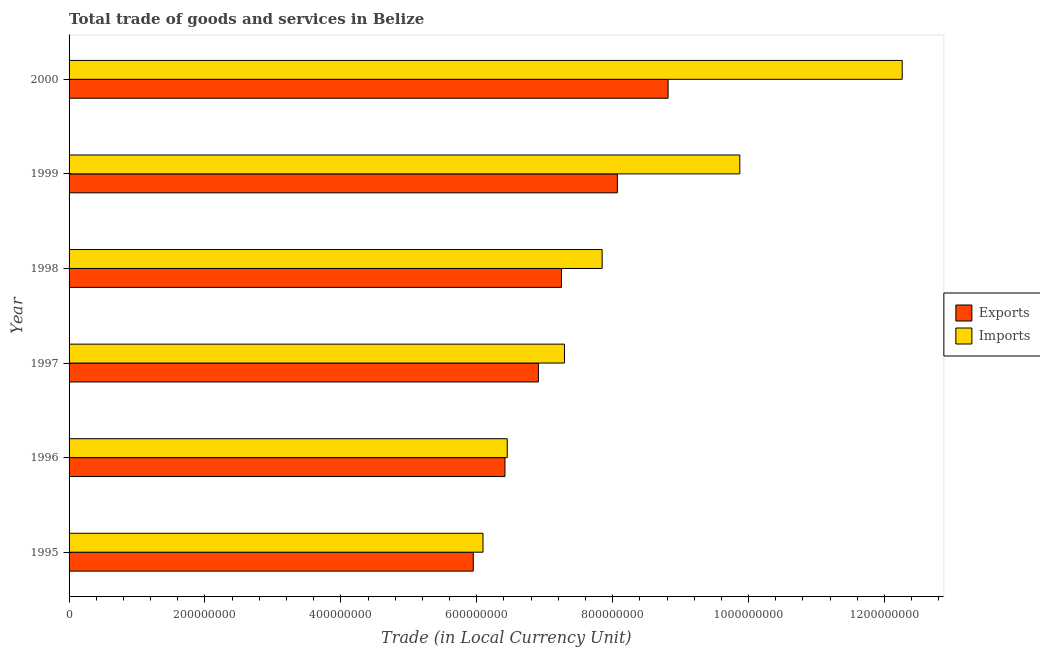Are the number of bars per tick equal to the number of legend labels?
Offer a very short reply. Yes. Are the number of bars on each tick of the Y-axis equal?
Offer a terse response. Yes. How many bars are there on the 3rd tick from the top?
Ensure brevity in your answer.  2. How many bars are there on the 3rd tick from the bottom?
Keep it short and to the point. 2. What is the label of the 6th group of bars from the top?
Give a very brief answer. 1995. In how many cases, is the number of bars for a given year not equal to the number of legend labels?
Your answer should be very brief. 0. What is the imports of goods and services in 2000?
Your response must be concise. 1.23e+09. Across all years, what is the maximum imports of goods and services?
Offer a terse response. 1.23e+09. Across all years, what is the minimum export of goods and services?
Your answer should be very brief. 5.95e+08. What is the total imports of goods and services in the graph?
Offer a terse response. 4.98e+09. What is the difference between the export of goods and services in 1995 and that in 1999?
Offer a terse response. -2.12e+08. What is the difference between the imports of goods and services in 2000 and the export of goods and services in 1996?
Make the answer very short. 5.85e+08. What is the average export of goods and services per year?
Offer a very short reply. 7.23e+08. In the year 2000, what is the difference between the export of goods and services and imports of goods and services?
Ensure brevity in your answer.  -3.44e+08. What is the ratio of the export of goods and services in 1999 to that in 2000?
Your response must be concise. 0.92. What is the difference between the highest and the second highest imports of goods and services?
Provide a short and direct response. 2.39e+08. What is the difference between the highest and the lowest imports of goods and services?
Provide a succinct answer. 6.17e+08. Is the sum of the imports of goods and services in 1995 and 1998 greater than the maximum export of goods and services across all years?
Provide a short and direct response. Yes. What does the 2nd bar from the top in 1996 represents?
Offer a very short reply. Exports. What does the 2nd bar from the bottom in 1998 represents?
Ensure brevity in your answer.  Imports. Are the values on the major ticks of X-axis written in scientific E-notation?
Your answer should be compact. No. Where does the legend appear in the graph?
Your answer should be compact. Center right. What is the title of the graph?
Make the answer very short. Total trade of goods and services in Belize. What is the label or title of the X-axis?
Offer a very short reply. Trade (in Local Currency Unit). What is the label or title of the Y-axis?
Your answer should be very brief. Year. What is the Trade (in Local Currency Unit) in Exports in 1995?
Provide a short and direct response. 5.95e+08. What is the Trade (in Local Currency Unit) in Imports in 1995?
Your answer should be compact. 6.09e+08. What is the Trade (in Local Currency Unit) of Exports in 1996?
Your response must be concise. 6.41e+08. What is the Trade (in Local Currency Unit) in Imports in 1996?
Ensure brevity in your answer.  6.45e+08. What is the Trade (in Local Currency Unit) in Exports in 1997?
Offer a terse response. 6.91e+08. What is the Trade (in Local Currency Unit) of Imports in 1997?
Offer a very short reply. 7.29e+08. What is the Trade (in Local Currency Unit) of Exports in 1998?
Provide a short and direct response. 7.25e+08. What is the Trade (in Local Currency Unit) of Imports in 1998?
Offer a very short reply. 7.84e+08. What is the Trade (in Local Currency Unit) in Exports in 1999?
Make the answer very short. 8.07e+08. What is the Trade (in Local Currency Unit) of Imports in 1999?
Ensure brevity in your answer.  9.87e+08. What is the Trade (in Local Currency Unit) of Exports in 2000?
Make the answer very short. 8.82e+08. What is the Trade (in Local Currency Unit) of Imports in 2000?
Provide a succinct answer. 1.23e+09. Across all years, what is the maximum Trade (in Local Currency Unit) of Exports?
Give a very brief answer. 8.82e+08. Across all years, what is the maximum Trade (in Local Currency Unit) of Imports?
Offer a very short reply. 1.23e+09. Across all years, what is the minimum Trade (in Local Currency Unit) in Exports?
Ensure brevity in your answer.  5.95e+08. Across all years, what is the minimum Trade (in Local Currency Unit) of Imports?
Your answer should be compact. 6.09e+08. What is the total Trade (in Local Currency Unit) of Exports in the graph?
Your answer should be compact. 4.34e+09. What is the total Trade (in Local Currency Unit) of Imports in the graph?
Make the answer very short. 4.98e+09. What is the difference between the Trade (in Local Currency Unit) in Exports in 1995 and that in 1996?
Provide a succinct answer. -4.66e+07. What is the difference between the Trade (in Local Currency Unit) in Imports in 1995 and that in 1996?
Make the answer very short. -3.57e+07. What is the difference between the Trade (in Local Currency Unit) in Exports in 1995 and that in 1997?
Offer a very short reply. -9.58e+07. What is the difference between the Trade (in Local Currency Unit) of Imports in 1995 and that in 1997?
Your answer should be compact. -1.20e+08. What is the difference between the Trade (in Local Currency Unit) of Exports in 1995 and that in 1998?
Your response must be concise. -1.30e+08. What is the difference between the Trade (in Local Currency Unit) of Imports in 1995 and that in 1998?
Provide a succinct answer. -1.75e+08. What is the difference between the Trade (in Local Currency Unit) of Exports in 1995 and that in 1999?
Ensure brevity in your answer.  -2.12e+08. What is the difference between the Trade (in Local Currency Unit) in Imports in 1995 and that in 1999?
Provide a succinct answer. -3.78e+08. What is the difference between the Trade (in Local Currency Unit) of Exports in 1995 and that in 2000?
Give a very brief answer. -2.87e+08. What is the difference between the Trade (in Local Currency Unit) of Imports in 1995 and that in 2000?
Offer a very short reply. -6.17e+08. What is the difference between the Trade (in Local Currency Unit) in Exports in 1996 and that in 1997?
Your answer should be compact. -4.93e+07. What is the difference between the Trade (in Local Currency Unit) in Imports in 1996 and that in 1997?
Provide a short and direct response. -8.42e+07. What is the difference between the Trade (in Local Currency Unit) of Exports in 1996 and that in 1998?
Keep it short and to the point. -8.31e+07. What is the difference between the Trade (in Local Currency Unit) in Imports in 1996 and that in 1998?
Offer a terse response. -1.40e+08. What is the difference between the Trade (in Local Currency Unit) in Exports in 1996 and that in 1999?
Keep it short and to the point. -1.65e+08. What is the difference between the Trade (in Local Currency Unit) in Imports in 1996 and that in 1999?
Give a very brief answer. -3.42e+08. What is the difference between the Trade (in Local Currency Unit) in Exports in 1996 and that in 2000?
Offer a terse response. -2.40e+08. What is the difference between the Trade (in Local Currency Unit) in Imports in 1996 and that in 2000?
Provide a succinct answer. -5.81e+08. What is the difference between the Trade (in Local Currency Unit) of Exports in 1997 and that in 1998?
Provide a succinct answer. -3.39e+07. What is the difference between the Trade (in Local Currency Unit) in Imports in 1997 and that in 1998?
Your response must be concise. -5.55e+07. What is the difference between the Trade (in Local Currency Unit) in Exports in 1997 and that in 1999?
Offer a terse response. -1.16e+08. What is the difference between the Trade (in Local Currency Unit) of Imports in 1997 and that in 1999?
Make the answer very short. -2.58e+08. What is the difference between the Trade (in Local Currency Unit) in Exports in 1997 and that in 2000?
Your answer should be compact. -1.91e+08. What is the difference between the Trade (in Local Currency Unit) in Imports in 1997 and that in 2000?
Your answer should be very brief. -4.97e+08. What is the difference between the Trade (in Local Currency Unit) in Exports in 1998 and that in 1999?
Your response must be concise. -8.23e+07. What is the difference between the Trade (in Local Currency Unit) of Imports in 1998 and that in 1999?
Provide a succinct answer. -2.03e+08. What is the difference between the Trade (in Local Currency Unit) in Exports in 1998 and that in 2000?
Keep it short and to the point. -1.57e+08. What is the difference between the Trade (in Local Currency Unit) in Imports in 1998 and that in 2000?
Your response must be concise. -4.42e+08. What is the difference between the Trade (in Local Currency Unit) in Exports in 1999 and that in 2000?
Ensure brevity in your answer.  -7.47e+07. What is the difference between the Trade (in Local Currency Unit) of Imports in 1999 and that in 2000?
Offer a very short reply. -2.39e+08. What is the difference between the Trade (in Local Currency Unit) in Exports in 1995 and the Trade (in Local Currency Unit) in Imports in 1996?
Your response must be concise. -4.99e+07. What is the difference between the Trade (in Local Currency Unit) of Exports in 1995 and the Trade (in Local Currency Unit) of Imports in 1997?
Provide a short and direct response. -1.34e+08. What is the difference between the Trade (in Local Currency Unit) in Exports in 1995 and the Trade (in Local Currency Unit) in Imports in 1998?
Your answer should be compact. -1.90e+08. What is the difference between the Trade (in Local Currency Unit) in Exports in 1995 and the Trade (in Local Currency Unit) in Imports in 1999?
Your answer should be very brief. -3.92e+08. What is the difference between the Trade (in Local Currency Unit) in Exports in 1995 and the Trade (in Local Currency Unit) in Imports in 2000?
Offer a terse response. -6.31e+08. What is the difference between the Trade (in Local Currency Unit) of Exports in 1996 and the Trade (in Local Currency Unit) of Imports in 1997?
Offer a terse response. -8.76e+07. What is the difference between the Trade (in Local Currency Unit) in Exports in 1996 and the Trade (in Local Currency Unit) in Imports in 1998?
Your response must be concise. -1.43e+08. What is the difference between the Trade (in Local Currency Unit) of Exports in 1996 and the Trade (in Local Currency Unit) of Imports in 1999?
Offer a terse response. -3.46e+08. What is the difference between the Trade (in Local Currency Unit) of Exports in 1996 and the Trade (in Local Currency Unit) of Imports in 2000?
Make the answer very short. -5.85e+08. What is the difference between the Trade (in Local Currency Unit) in Exports in 1997 and the Trade (in Local Currency Unit) in Imports in 1998?
Your response must be concise. -9.38e+07. What is the difference between the Trade (in Local Currency Unit) in Exports in 1997 and the Trade (in Local Currency Unit) in Imports in 1999?
Your response must be concise. -2.96e+08. What is the difference between the Trade (in Local Currency Unit) in Exports in 1997 and the Trade (in Local Currency Unit) in Imports in 2000?
Provide a short and direct response. -5.35e+08. What is the difference between the Trade (in Local Currency Unit) of Exports in 1998 and the Trade (in Local Currency Unit) of Imports in 1999?
Make the answer very short. -2.62e+08. What is the difference between the Trade (in Local Currency Unit) of Exports in 1998 and the Trade (in Local Currency Unit) of Imports in 2000?
Keep it short and to the point. -5.01e+08. What is the difference between the Trade (in Local Currency Unit) in Exports in 1999 and the Trade (in Local Currency Unit) in Imports in 2000?
Offer a very short reply. -4.19e+08. What is the average Trade (in Local Currency Unit) in Exports per year?
Ensure brevity in your answer.  7.23e+08. What is the average Trade (in Local Currency Unit) of Imports per year?
Provide a succinct answer. 8.30e+08. In the year 1995, what is the difference between the Trade (in Local Currency Unit) in Exports and Trade (in Local Currency Unit) in Imports?
Give a very brief answer. -1.43e+07. In the year 1996, what is the difference between the Trade (in Local Currency Unit) of Exports and Trade (in Local Currency Unit) of Imports?
Offer a very short reply. -3.37e+06. In the year 1997, what is the difference between the Trade (in Local Currency Unit) in Exports and Trade (in Local Currency Unit) in Imports?
Your answer should be very brief. -3.83e+07. In the year 1998, what is the difference between the Trade (in Local Currency Unit) of Exports and Trade (in Local Currency Unit) of Imports?
Keep it short and to the point. -5.99e+07. In the year 1999, what is the difference between the Trade (in Local Currency Unit) of Exports and Trade (in Local Currency Unit) of Imports?
Offer a very short reply. -1.80e+08. In the year 2000, what is the difference between the Trade (in Local Currency Unit) of Exports and Trade (in Local Currency Unit) of Imports?
Keep it short and to the point. -3.44e+08. What is the ratio of the Trade (in Local Currency Unit) of Exports in 1995 to that in 1996?
Offer a very short reply. 0.93. What is the ratio of the Trade (in Local Currency Unit) of Imports in 1995 to that in 1996?
Your answer should be compact. 0.94. What is the ratio of the Trade (in Local Currency Unit) of Exports in 1995 to that in 1997?
Keep it short and to the point. 0.86. What is the ratio of the Trade (in Local Currency Unit) of Imports in 1995 to that in 1997?
Ensure brevity in your answer.  0.84. What is the ratio of the Trade (in Local Currency Unit) of Exports in 1995 to that in 1998?
Offer a very short reply. 0.82. What is the ratio of the Trade (in Local Currency Unit) of Imports in 1995 to that in 1998?
Offer a very short reply. 0.78. What is the ratio of the Trade (in Local Currency Unit) of Exports in 1995 to that in 1999?
Give a very brief answer. 0.74. What is the ratio of the Trade (in Local Currency Unit) of Imports in 1995 to that in 1999?
Keep it short and to the point. 0.62. What is the ratio of the Trade (in Local Currency Unit) in Exports in 1995 to that in 2000?
Your answer should be compact. 0.67. What is the ratio of the Trade (in Local Currency Unit) in Imports in 1995 to that in 2000?
Give a very brief answer. 0.5. What is the ratio of the Trade (in Local Currency Unit) in Exports in 1996 to that in 1997?
Ensure brevity in your answer.  0.93. What is the ratio of the Trade (in Local Currency Unit) of Imports in 1996 to that in 1997?
Provide a succinct answer. 0.88. What is the ratio of the Trade (in Local Currency Unit) of Exports in 1996 to that in 1998?
Offer a very short reply. 0.89. What is the ratio of the Trade (in Local Currency Unit) in Imports in 1996 to that in 1998?
Your answer should be very brief. 0.82. What is the ratio of the Trade (in Local Currency Unit) in Exports in 1996 to that in 1999?
Keep it short and to the point. 0.8. What is the ratio of the Trade (in Local Currency Unit) of Imports in 1996 to that in 1999?
Provide a short and direct response. 0.65. What is the ratio of the Trade (in Local Currency Unit) in Exports in 1996 to that in 2000?
Offer a terse response. 0.73. What is the ratio of the Trade (in Local Currency Unit) of Imports in 1996 to that in 2000?
Provide a short and direct response. 0.53. What is the ratio of the Trade (in Local Currency Unit) of Exports in 1997 to that in 1998?
Offer a terse response. 0.95. What is the ratio of the Trade (in Local Currency Unit) of Imports in 1997 to that in 1998?
Keep it short and to the point. 0.93. What is the ratio of the Trade (in Local Currency Unit) in Exports in 1997 to that in 1999?
Ensure brevity in your answer.  0.86. What is the ratio of the Trade (in Local Currency Unit) in Imports in 1997 to that in 1999?
Ensure brevity in your answer.  0.74. What is the ratio of the Trade (in Local Currency Unit) in Exports in 1997 to that in 2000?
Offer a very short reply. 0.78. What is the ratio of the Trade (in Local Currency Unit) of Imports in 1997 to that in 2000?
Your answer should be very brief. 0.59. What is the ratio of the Trade (in Local Currency Unit) of Exports in 1998 to that in 1999?
Keep it short and to the point. 0.9. What is the ratio of the Trade (in Local Currency Unit) of Imports in 1998 to that in 1999?
Offer a terse response. 0.79. What is the ratio of the Trade (in Local Currency Unit) of Exports in 1998 to that in 2000?
Give a very brief answer. 0.82. What is the ratio of the Trade (in Local Currency Unit) in Imports in 1998 to that in 2000?
Ensure brevity in your answer.  0.64. What is the ratio of the Trade (in Local Currency Unit) in Exports in 1999 to that in 2000?
Keep it short and to the point. 0.92. What is the ratio of the Trade (in Local Currency Unit) of Imports in 1999 to that in 2000?
Provide a succinct answer. 0.81. What is the difference between the highest and the second highest Trade (in Local Currency Unit) of Exports?
Your answer should be very brief. 7.47e+07. What is the difference between the highest and the second highest Trade (in Local Currency Unit) of Imports?
Your answer should be very brief. 2.39e+08. What is the difference between the highest and the lowest Trade (in Local Currency Unit) in Exports?
Provide a succinct answer. 2.87e+08. What is the difference between the highest and the lowest Trade (in Local Currency Unit) in Imports?
Your answer should be compact. 6.17e+08. 